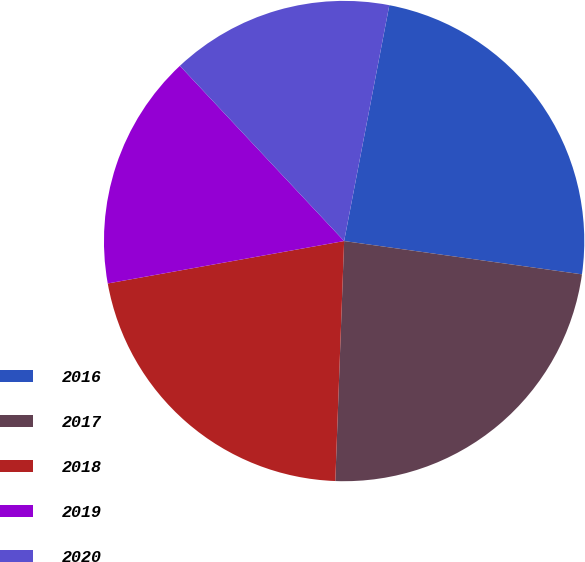<chart> <loc_0><loc_0><loc_500><loc_500><pie_chart><fcel>2016<fcel>2017<fcel>2018<fcel>2019<fcel>2020<nl><fcel>24.2%<fcel>23.37%<fcel>21.59%<fcel>15.84%<fcel>15.0%<nl></chart> 